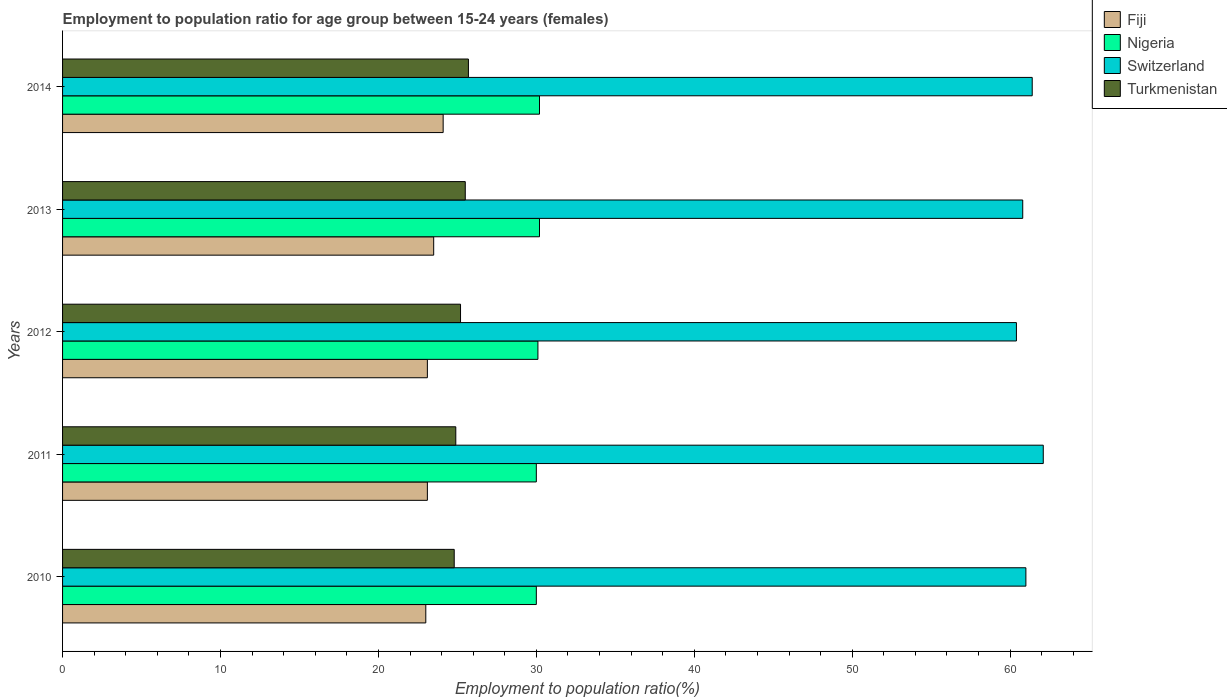How many groups of bars are there?
Make the answer very short. 5. How many bars are there on the 3rd tick from the bottom?
Keep it short and to the point. 4. What is the label of the 4th group of bars from the top?
Provide a succinct answer. 2011. In how many cases, is the number of bars for a given year not equal to the number of legend labels?
Your answer should be very brief. 0. What is the employment to population ratio in Fiji in 2014?
Keep it short and to the point. 24.1. Across all years, what is the maximum employment to population ratio in Turkmenistan?
Offer a very short reply. 25.7. Across all years, what is the minimum employment to population ratio in Switzerland?
Offer a terse response. 60.4. In which year was the employment to population ratio in Fiji maximum?
Give a very brief answer. 2014. In which year was the employment to population ratio in Turkmenistan minimum?
Provide a short and direct response. 2010. What is the total employment to population ratio in Nigeria in the graph?
Offer a very short reply. 150.5. What is the difference between the employment to population ratio in Nigeria in 2010 and that in 2012?
Give a very brief answer. -0.1. What is the difference between the employment to population ratio in Fiji in 2010 and the employment to population ratio in Switzerland in 2013?
Provide a succinct answer. -37.8. What is the average employment to population ratio in Turkmenistan per year?
Your response must be concise. 25.22. In how many years, is the employment to population ratio in Fiji greater than 46 %?
Your answer should be compact. 0. What is the ratio of the employment to population ratio in Nigeria in 2011 to that in 2014?
Give a very brief answer. 0.99. Is the difference between the employment to population ratio in Fiji in 2012 and 2014 greater than the difference between the employment to population ratio in Turkmenistan in 2012 and 2014?
Provide a short and direct response. No. What is the difference between the highest and the second highest employment to population ratio in Fiji?
Offer a very short reply. 0.6. What is the difference between the highest and the lowest employment to population ratio in Fiji?
Offer a very short reply. 1.1. Is it the case that in every year, the sum of the employment to population ratio in Nigeria and employment to population ratio in Turkmenistan is greater than the sum of employment to population ratio in Fiji and employment to population ratio in Switzerland?
Give a very brief answer. Yes. What does the 2nd bar from the top in 2011 represents?
Give a very brief answer. Switzerland. What does the 4th bar from the bottom in 2010 represents?
Ensure brevity in your answer.  Turkmenistan. Is it the case that in every year, the sum of the employment to population ratio in Turkmenistan and employment to population ratio in Switzerland is greater than the employment to population ratio in Nigeria?
Your response must be concise. Yes. How many bars are there?
Your answer should be very brief. 20. Are all the bars in the graph horizontal?
Your response must be concise. Yes. What is the difference between two consecutive major ticks on the X-axis?
Provide a succinct answer. 10. Are the values on the major ticks of X-axis written in scientific E-notation?
Provide a short and direct response. No. Does the graph contain any zero values?
Provide a succinct answer. No. Does the graph contain grids?
Provide a short and direct response. No. How many legend labels are there?
Your response must be concise. 4. How are the legend labels stacked?
Your answer should be compact. Vertical. What is the title of the graph?
Offer a terse response. Employment to population ratio for age group between 15-24 years (females). Does "Equatorial Guinea" appear as one of the legend labels in the graph?
Give a very brief answer. No. What is the label or title of the Y-axis?
Your response must be concise. Years. What is the Employment to population ratio(%) in Fiji in 2010?
Ensure brevity in your answer.  23. What is the Employment to population ratio(%) of Nigeria in 2010?
Keep it short and to the point. 30. What is the Employment to population ratio(%) of Turkmenistan in 2010?
Offer a terse response. 24.8. What is the Employment to population ratio(%) in Fiji in 2011?
Your answer should be very brief. 23.1. What is the Employment to population ratio(%) in Switzerland in 2011?
Provide a short and direct response. 62.1. What is the Employment to population ratio(%) of Turkmenistan in 2011?
Offer a terse response. 24.9. What is the Employment to population ratio(%) of Fiji in 2012?
Give a very brief answer. 23.1. What is the Employment to population ratio(%) of Nigeria in 2012?
Provide a succinct answer. 30.1. What is the Employment to population ratio(%) in Switzerland in 2012?
Provide a short and direct response. 60.4. What is the Employment to population ratio(%) of Turkmenistan in 2012?
Your response must be concise. 25.2. What is the Employment to population ratio(%) in Fiji in 2013?
Provide a succinct answer. 23.5. What is the Employment to population ratio(%) of Nigeria in 2013?
Keep it short and to the point. 30.2. What is the Employment to population ratio(%) of Switzerland in 2013?
Offer a very short reply. 60.8. What is the Employment to population ratio(%) of Fiji in 2014?
Your answer should be very brief. 24.1. What is the Employment to population ratio(%) in Nigeria in 2014?
Ensure brevity in your answer.  30.2. What is the Employment to population ratio(%) in Switzerland in 2014?
Make the answer very short. 61.4. What is the Employment to population ratio(%) of Turkmenistan in 2014?
Offer a very short reply. 25.7. Across all years, what is the maximum Employment to population ratio(%) in Fiji?
Ensure brevity in your answer.  24.1. Across all years, what is the maximum Employment to population ratio(%) of Nigeria?
Your response must be concise. 30.2. Across all years, what is the maximum Employment to population ratio(%) of Switzerland?
Offer a very short reply. 62.1. Across all years, what is the maximum Employment to population ratio(%) of Turkmenistan?
Provide a succinct answer. 25.7. Across all years, what is the minimum Employment to population ratio(%) in Fiji?
Ensure brevity in your answer.  23. Across all years, what is the minimum Employment to population ratio(%) of Switzerland?
Provide a short and direct response. 60.4. Across all years, what is the minimum Employment to population ratio(%) of Turkmenistan?
Offer a very short reply. 24.8. What is the total Employment to population ratio(%) of Fiji in the graph?
Your response must be concise. 116.8. What is the total Employment to population ratio(%) in Nigeria in the graph?
Your answer should be very brief. 150.5. What is the total Employment to population ratio(%) in Switzerland in the graph?
Your answer should be compact. 305.7. What is the total Employment to population ratio(%) in Turkmenistan in the graph?
Make the answer very short. 126.1. What is the difference between the Employment to population ratio(%) in Fiji in 2010 and that in 2011?
Provide a short and direct response. -0.1. What is the difference between the Employment to population ratio(%) of Nigeria in 2010 and that in 2011?
Keep it short and to the point. 0. What is the difference between the Employment to population ratio(%) of Switzerland in 2010 and that in 2011?
Make the answer very short. -1.1. What is the difference between the Employment to population ratio(%) in Turkmenistan in 2010 and that in 2011?
Make the answer very short. -0.1. What is the difference between the Employment to population ratio(%) of Turkmenistan in 2010 and that in 2012?
Provide a short and direct response. -0.4. What is the difference between the Employment to population ratio(%) in Fiji in 2010 and that in 2013?
Give a very brief answer. -0.5. What is the difference between the Employment to population ratio(%) of Switzerland in 2010 and that in 2013?
Give a very brief answer. 0.2. What is the difference between the Employment to population ratio(%) of Turkmenistan in 2010 and that in 2013?
Give a very brief answer. -0.7. What is the difference between the Employment to population ratio(%) in Nigeria in 2010 and that in 2014?
Provide a succinct answer. -0.2. What is the difference between the Employment to population ratio(%) in Switzerland in 2010 and that in 2014?
Keep it short and to the point. -0.4. What is the difference between the Employment to population ratio(%) of Fiji in 2011 and that in 2012?
Offer a very short reply. 0. What is the difference between the Employment to population ratio(%) of Nigeria in 2011 and that in 2012?
Your answer should be compact. -0.1. What is the difference between the Employment to population ratio(%) of Fiji in 2011 and that in 2013?
Your response must be concise. -0.4. What is the difference between the Employment to population ratio(%) of Switzerland in 2011 and that in 2013?
Give a very brief answer. 1.3. What is the difference between the Employment to population ratio(%) of Turkmenistan in 2011 and that in 2013?
Ensure brevity in your answer.  -0.6. What is the difference between the Employment to population ratio(%) of Fiji in 2011 and that in 2014?
Provide a succinct answer. -1. What is the difference between the Employment to population ratio(%) in Nigeria in 2011 and that in 2014?
Give a very brief answer. -0.2. What is the difference between the Employment to population ratio(%) of Fiji in 2012 and that in 2013?
Offer a very short reply. -0.4. What is the difference between the Employment to population ratio(%) in Fiji in 2012 and that in 2014?
Provide a succinct answer. -1. What is the difference between the Employment to population ratio(%) in Turkmenistan in 2012 and that in 2014?
Offer a very short reply. -0.5. What is the difference between the Employment to population ratio(%) of Nigeria in 2013 and that in 2014?
Provide a short and direct response. 0. What is the difference between the Employment to population ratio(%) of Switzerland in 2013 and that in 2014?
Your response must be concise. -0.6. What is the difference between the Employment to population ratio(%) of Turkmenistan in 2013 and that in 2014?
Your answer should be very brief. -0.2. What is the difference between the Employment to population ratio(%) in Fiji in 2010 and the Employment to population ratio(%) in Nigeria in 2011?
Provide a succinct answer. -7. What is the difference between the Employment to population ratio(%) in Fiji in 2010 and the Employment to population ratio(%) in Switzerland in 2011?
Your answer should be very brief. -39.1. What is the difference between the Employment to population ratio(%) in Nigeria in 2010 and the Employment to population ratio(%) in Switzerland in 2011?
Offer a very short reply. -32.1. What is the difference between the Employment to population ratio(%) of Switzerland in 2010 and the Employment to population ratio(%) of Turkmenistan in 2011?
Ensure brevity in your answer.  36.1. What is the difference between the Employment to population ratio(%) of Fiji in 2010 and the Employment to population ratio(%) of Nigeria in 2012?
Make the answer very short. -7.1. What is the difference between the Employment to population ratio(%) in Fiji in 2010 and the Employment to population ratio(%) in Switzerland in 2012?
Your answer should be very brief. -37.4. What is the difference between the Employment to population ratio(%) of Nigeria in 2010 and the Employment to population ratio(%) of Switzerland in 2012?
Ensure brevity in your answer.  -30.4. What is the difference between the Employment to population ratio(%) of Switzerland in 2010 and the Employment to population ratio(%) of Turkmenistan in 2012?
Make the answer very short. 35.8. What is the difference between the Employment to population ratio(%) in Fiji in 2010 and the Employment to population ratio(%) in Nigeria in 2013?
Provide a short and direct response. -7.2. What is the difference between the Employment to population ratio(%) of Fiji in 2010 and the Employment to population ratio(%) of Switzerland in 2013?
Give a very brief answer. -37.8. What is the difference between the Employment to population ratio(%) of Fiji in 2010 and the Employment to population ratio(%) of Turkmenistan in 2013?
Your response must be concise. -2.5. What is the difference between the Employment to population ratio(%) in Nigeria in 2010 and the Employment to population ratio(%) in Switzerland in 2013?
Your answer should be very brief. -30.8. What is the difference between the Employment to population ratio(%) of Switzerland in 2010 and the Employment to population ratio(%) of Turkmenistan in 2013?
Offer a very short reply. 35.5. What is the difference between the Employment to population ratio(%) in Fiji in 2010 and the Employment to population ratio(%) in Switzerland in 2014?
Ensure brevity in your answer.  -38.4. What is the difference between the Employment to population ratio(%) of Fiji in 2010 and the Employment to population ratio(%) of Turkmenistan in 2014?
Your response must be concise. -2.7. What is the difference between the Employment to population ratio(%) of Nigeria in 2010 and the Employment to population ratio(%) of Switzerland in 2014?
Make the answer very short. -31.4. What is the difference between the Employment to population ratio(%) of Switzerland in 2010 and the Employment to population ratio(%) of Turkmenistan in 2014?
Your answer should be compact. 35.3. What is the difference between the Employment to population ratio(%) of Fiji in 2011 and the Employment to population ratio(%) of Switzerland in 2012?
Your answer should be very brief. -37.3. What is the difference between the Employment to population ratio(%) of Nigeria in 2011 and the Employment to population ratio(%) of Switzerland in 2012?
Give a very brief answer. -30.4. What is the difference between the Employment to population ratio(%) in Nigeria in 2011 and the Employment to population ratio(%) in Turkmenistan in 2012?
Your answer should be compact. 4.8. What is the difference between the Employment to population ratio(%) in Switzerland in 2011 and the Employment to population ratio(%) in Turkmenistan in 2012?
Make the answer very short. 36.9. What is the difference between the Employment to population ratio(%) of Fiji in 2011 and the Employment to population ratio(%) of Nigeria in 2013?
Make the answer very short. -7.1. What is the difference between the Employment to population ratio(%) in Fiji in 2011 and the Employment to population ratio(%) in Switzerland in 2013?
Ensure brevity in your answer.  -37.7. What is the difference between the Employment to population ratio(%) of Fiji in 2011 and the Employment to population ratio(%) of Turkmenistan in 2013?
Offer a very short reply. -2.4. What is the difference between the Employment to population ratio(%) of Nigeria in 2011 and the Employment to population ratio(%) of Switzerland in 2013?
Make the answer very short. -30.8. What is the difference between the Employment to population ratio(%) of Switzerland in 2011 and the Employment to population ratio(%) of Turkmenistan in 2013?
Provide a short and direct response. 36.6. What is the difference between the Employment to population ratio(%) in Fiji in 2011 and the Employment to population ratio(%) in Switzerland in 2014?
Offer a terse response. -38.3. What is the difference between the Employment to population ratio(%) of Fiji in 2011 and the Employment to population ratio(%) of Turkmenistan in 2014?
Offer a very short reply. -2.6. What is the difference between the Employment to population ratio(%) in Nigeria in 2011 and the Employment to population ratio(%) in Switzerland in 2014?
Offer a terse response. -31.4. What is the difference between the Employment to population ratio(%) of Switzerland in 2011 and the Employment to population ratio(%) of Turkmenistan in 2014?
Make the answer very short. 36.4. What is the difference between the Employment to population ratio(%) of Fiji in 2012 and the Employment to population ratio(%) of Switzerland in 2013?
Give a very brief answer. -37.7. What is the difference between the Employment to population ratio(%) in Fiji in 2012 and the Employment to population ratio(%) in Turkmenistan in 2013?
Give a very brief answer. -2.4. What is the difference between the Employment to population ratio(%) in Nigeria in 2012 and the Employment to population ratio(%) in Switzerland in 2013?
Provide a succinct answer. -30.7. What is the difference between the Employment to population ratio(%) in Switzerland in 2012 and the Employment to population ratio(%) in Turkmenistan in 2013?
Your response must be concise. 34.9. What is the difference between the Employment to population ratio(%) in Fiji in 2012 and the Employment to population ratio(%) in Nigeria in 2014?
Offer a terse response. -7.1. What is the difference between the Employment to population ratio(%) of Fiji in 2012 and the Employment to population ratio(%) of Switzerland in 2014?
Offer a terse response. -38.3. What is the difference between the Employment to population ratio(%) in Fiji in 2012 and the Employment to population ratio(%) in Turkmenistan in 2014?
Your answer should be very brief. -2.6. What is the difference between the Employment to population ratio(%) of Nigeria in 2012 and the Employment to population ratio(%) of Switzerland in 2014?
Make the answer very short. -31.3. What is the difference between the Employment to population ratio(%) in Switzerland in 2012 and the Employment to population ratio(%) in Turkmenistan in 2014?
Provide a short and direct response. 34.7. What is the difference between the Employment to population ratio(%) in Fiji in 2013 and the Employment to population ratio(%) in Switzerland in 2014?
Your response must be concise. -37.9. What is the difference between the Employment to population ratio(%) of Nigeria in 2013 and the Employment to population ratio(%) of Switzerland in 2014?
Provide a succinct answer. -31.2. What is the difference between the Employment to population ratio(%) in Switzerland in 2013 and the Employment to population ratio(%) in Turkmenistan in 2014?
Your answer should be very brief. 35.1. What is the average Employment to population ratio(%) in Fiji per year?
Offer a terse response. 23.36. What is the average Employment to population ratio(%) in Nigeria per year?
Your response must be concise. 30.1. What is the average Employment to population ratio(%) of Switzerland per year?
Make the answer very short. 61.14. What is the average Employment to population ratio(%) in Turkmenistan per year?
Your response must be concise. 25.22. In the year 2010, what is the difference between the Employment to population ratio(%) of Fiji and Employment to population ratio(%) of Nigeria?
Keep it short and to the point. -7. In the year 2010, what is the difference between the Employment to population ratio(%) of Fiji and Employment to population ratio(%) of Switzerland?
Your answer should be very brief. -38. In the year 2010, what is the difference between the Employment to population ratio(%) of Nigeria and Employment to population ratio(%) of Switzerland?
Your response must be concise. -31. In the year 2010, what is the difference between the Employment to population ratio(%) in Nigeria and Employment to population ratio(%) in Turkmenistan?
Your response must be concise. 5.2. In the year 2010, what is the difference between the Employment to population ratio(%) of Switzerland and Employment to population ratio(%) of Turkmenistan?
Make the answer very short. 36.2. In the year 2011, what is the difference between the Employment to population ratio(%) in Fiji and Employment to population ratio(%) in Switzerland?
Give a very brief answer. -39. In the year 2011, what is the difference between the Employment to population ratio(%) of Fiji and Employment to population ratio(%) of Turkmenistan?
Provide a succinct answer. -1.8. In the year 2011, what is the difference between the Employment to population ratio(%) of Nigeria and Employment to population ratio(%) of Switzerland?
Make the answer very short. -32.1. In the year 2011, what is the difference between the Employment to population ratio(%) of Nigeria and Employment to population ratio(%) of Turkmenistan?
Your response must be concise. 5.1. In the year 2011, what is the difference between the Employment to population ratio(%) of Switzerland and Employment to population ratio(%) of Turkmenistan?
Offer a terse response. 37.2. In the year 2012, what is the difference between the Employment to population ratio(%) in Fiji and Employment to population ratio(%) in Switzerland?
Keep it short and to the point. -37.3. In the year 2012, what is the difference between the Employment to population ratio(%) of Fiji and Employment to population ratio(%) of Turkmenistan?
Your answer should be very brief. -2.1. In the year 2012, what is the difference between the Employment to population ratio(%) of Nigeria and Employment to population ratio(%) of Switzerland?
Your response must be concise. -30.3. In the year 2012, what is the difference between the Employment to population ratio(%) in Nigeria and Employment to population ratio(%) in Turkmenistan?
Ensure brevity in your answer.  4.9. In the year 2012, what is the difference between the Employment to population ratio(%) of Switzerland and Employment to population ratio(%) of Turkmenistan?
Make the answer very short. 35.2. In the year 2013, what is the difference between the Employment to population ratio(%) in Fiji and Employment to population ratio(%) in Switzerland?
Your answer should be compact. -37.3. In the year 2013, what is the difference between the Employment to population ratio(%) in Fiji and Employment to population ratio(%) in Turkmenistan?
Keep it short and to the point. -2. In the year 2013, what is the difference between the Employment to population ratio(%) of Nigeria and Employment to population ratio(%) of Switzerland?
Ensure brevity in your answer.  -30.6. In the year 2013, what is the difference between the Employment to population ratio(%) of Nigeria and Employment to population ratio(%) of Turkmenistan?
Provide a short and direct response. 4.7. In the year 2013, what is the difference between the Employment to population ratio(%) of Switzerland and Employment to population ratio(%) of Turkmenistan?
Ensure brevity in your answer.  35.3. In the year 2014, what is the difference between the Employment to population ratio(%) of Fiji and Employment to population ratio(%) of Nigeria?
Ensure brevity in your answer.  -6.1. In the year 2014, what is the difference between the Employment to population ratio(%) of Fiji and Employment to population ratio(%) of Switzerland?
Offer a very short reply. -37.3. In the year 2014, what is the difference between the Employment to population ratio(%) of Nigeria and Employment to population ratio(%) of Switzerland?
Your answer should be very brief. -31.2. In the year 2014, what is the difference between the Employment to population ratio(%) of Switzerland and Employment to population ratio(%) of Turkmenistan?
Offer a terse response. 35.7. What is the ratio of the Employment to population ratio(%) of Switzerland in 2010 to that in 2011?
Offer a very short reply. 0.98. What is the ratio of the Employment to population ratio(%) in Fiji in 2010 to that in 2012?
Ensure brevity in your answer.  1. What is the ratio of the Employment to population ratio(%) of Switzerland in 2010 to that in 2012?
Give a very brief answer. 1.01. What is the ratio of the Employment to population ratio(%) of Turkmenistan in 2010 to that in 2012?
Your answer should be very brief. 0.98. What is the ratio of the Employment to population ratio(%) of Fiji in 2010 to that in 2013?
Provide a succinct answer. 0.98. What is the ratio of the Employment to population ratio(%) in Switzerland in 2010 to that in 2013?
Keep it short and to the point. 1. What is the ratio of the Employment to population ratio(%) in Turkmenistan in 2010 to that in 2013?
Offer a terse response. 0.97. What is the ratio of the Employment to population ratio(%) in Fiji in 2010 to that in 2014?
Give a very brief answer. 0.95. What is the ratio of the Employment to population ratio(%) of Switzerland in 2010 to that in 2014?
Provide a succinct answer. 0.99. What is the ratio of the Employment to population ratio(%) in Turkmenistan in 2010 to that in 2014?
Keep it short and to the point. 0.96. What is the ratio of the Employment to population ratio(%) in Switzerland in 2011 to that in 2012?
Give a very brief answer. 1.03. What is the ratio of the Employment to population ratio(%) in Turkmenistan in 2011 to that in 2012?
Offer a terse response. 0.99. What is the ratio of the Employment to population ratio(%) of Nigeria in 2011 to that in 2013?
Keep it short and to the point. 0.99. What is the ratio of the Employment to population ratio(%) in Switzerland in 2011 to that in 2013?
Provide a short and direct response. 1.02. What is the ratio of the Employment to population ratio(%) in Turkmenistan in 2011 to that in 2013?
Provide a succinct answer. 0.98. What is the ratio of the Employment to population ratio(%) in Fiji in 2011 to that in 2014?
Offer a terse response. 0.96. What is the ratio of the Employment to population ratio(%) of Nigeria in 2011 to that in 2014?
Make the answer very short. 0.99. What is the ratio of the Employment to population ratio(%) in Switzerland in 2011 to that in 2014?
Give a very brief answer. 1.01. What is the ratio of the Employment to population ratio(%) in Turkmenistan in 2011 to that in 2014?
Ensure brevity in your answer.  0.97. What is the ratio of the Employment to population ratio(%) in Fiji in 2012 to that in 2013?
Provide a short and direct response. 0.98. What is the ratio of the Employment to population ratio(%) of Switzerland in 2012 to that in 2013?
Ensure brevity in your answer.  0.99. What is the ratio of the Employment to population ratio(%) of Turkmenistan in 2012 to that in 2013?
Offer a terse response. 0.99. What is the ratio of the Employment to population ratio(%) in Fiji in 2012 to that in 2014?
Make the answer very short. 0.96. What is the ratio of the Employment to population ratio(%) of Nigeria in 2012 to that in 2014?
Keep it short and to the point. 1. What is the ratio of the Employment to population ratio(%) of Switzerland in 2012 to that in 2014?
Keep it short and to the point. 0.98. What is the ratio of the Employment to population ratio(%) of Turkmenistan in 2012 to that in 2014?
Provide a succinct answer. 0.98. What is the ratio of the Employment to population ratio(%) of Fiji in 2013 to that in 2014?
Offer a very short reply. 0.98. What is the ratio of the Employment to population ratio(%) in Switzerland in 2013 to that in 2014?
Your response must be concise. 0.99. What is the difference between the highest and the second highest Employment to population ratio(%) of Fiji?
Give a very brief answer. 0.6. What is the difference between the highest and the second highest Employment to population ratio(%) of Nigeria?
Your answer should be very brief. 0. What is the difference between the highest and the second highest Employment to population ratio(%) of Turkmenistan?
Offer a very short reply. 0.2. What is the difference between the highest and the lowest Employment to population ratio(%) of Fiji?
Offer a very short reply. 1.1. What is the difference between the highest and the lowest Employment to population ratio(%) in Switzerland?
Provide a short and direct response. 1.7. 